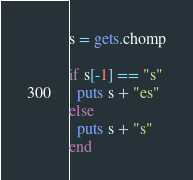Convert code to text. <code><loc_0><loc_0><loc_500><loc_500><_Ruby_>s = gets.chomp
 
if s[-1] == "s"
  puts s + "es"
else
  puts s + "s"
end</code> 